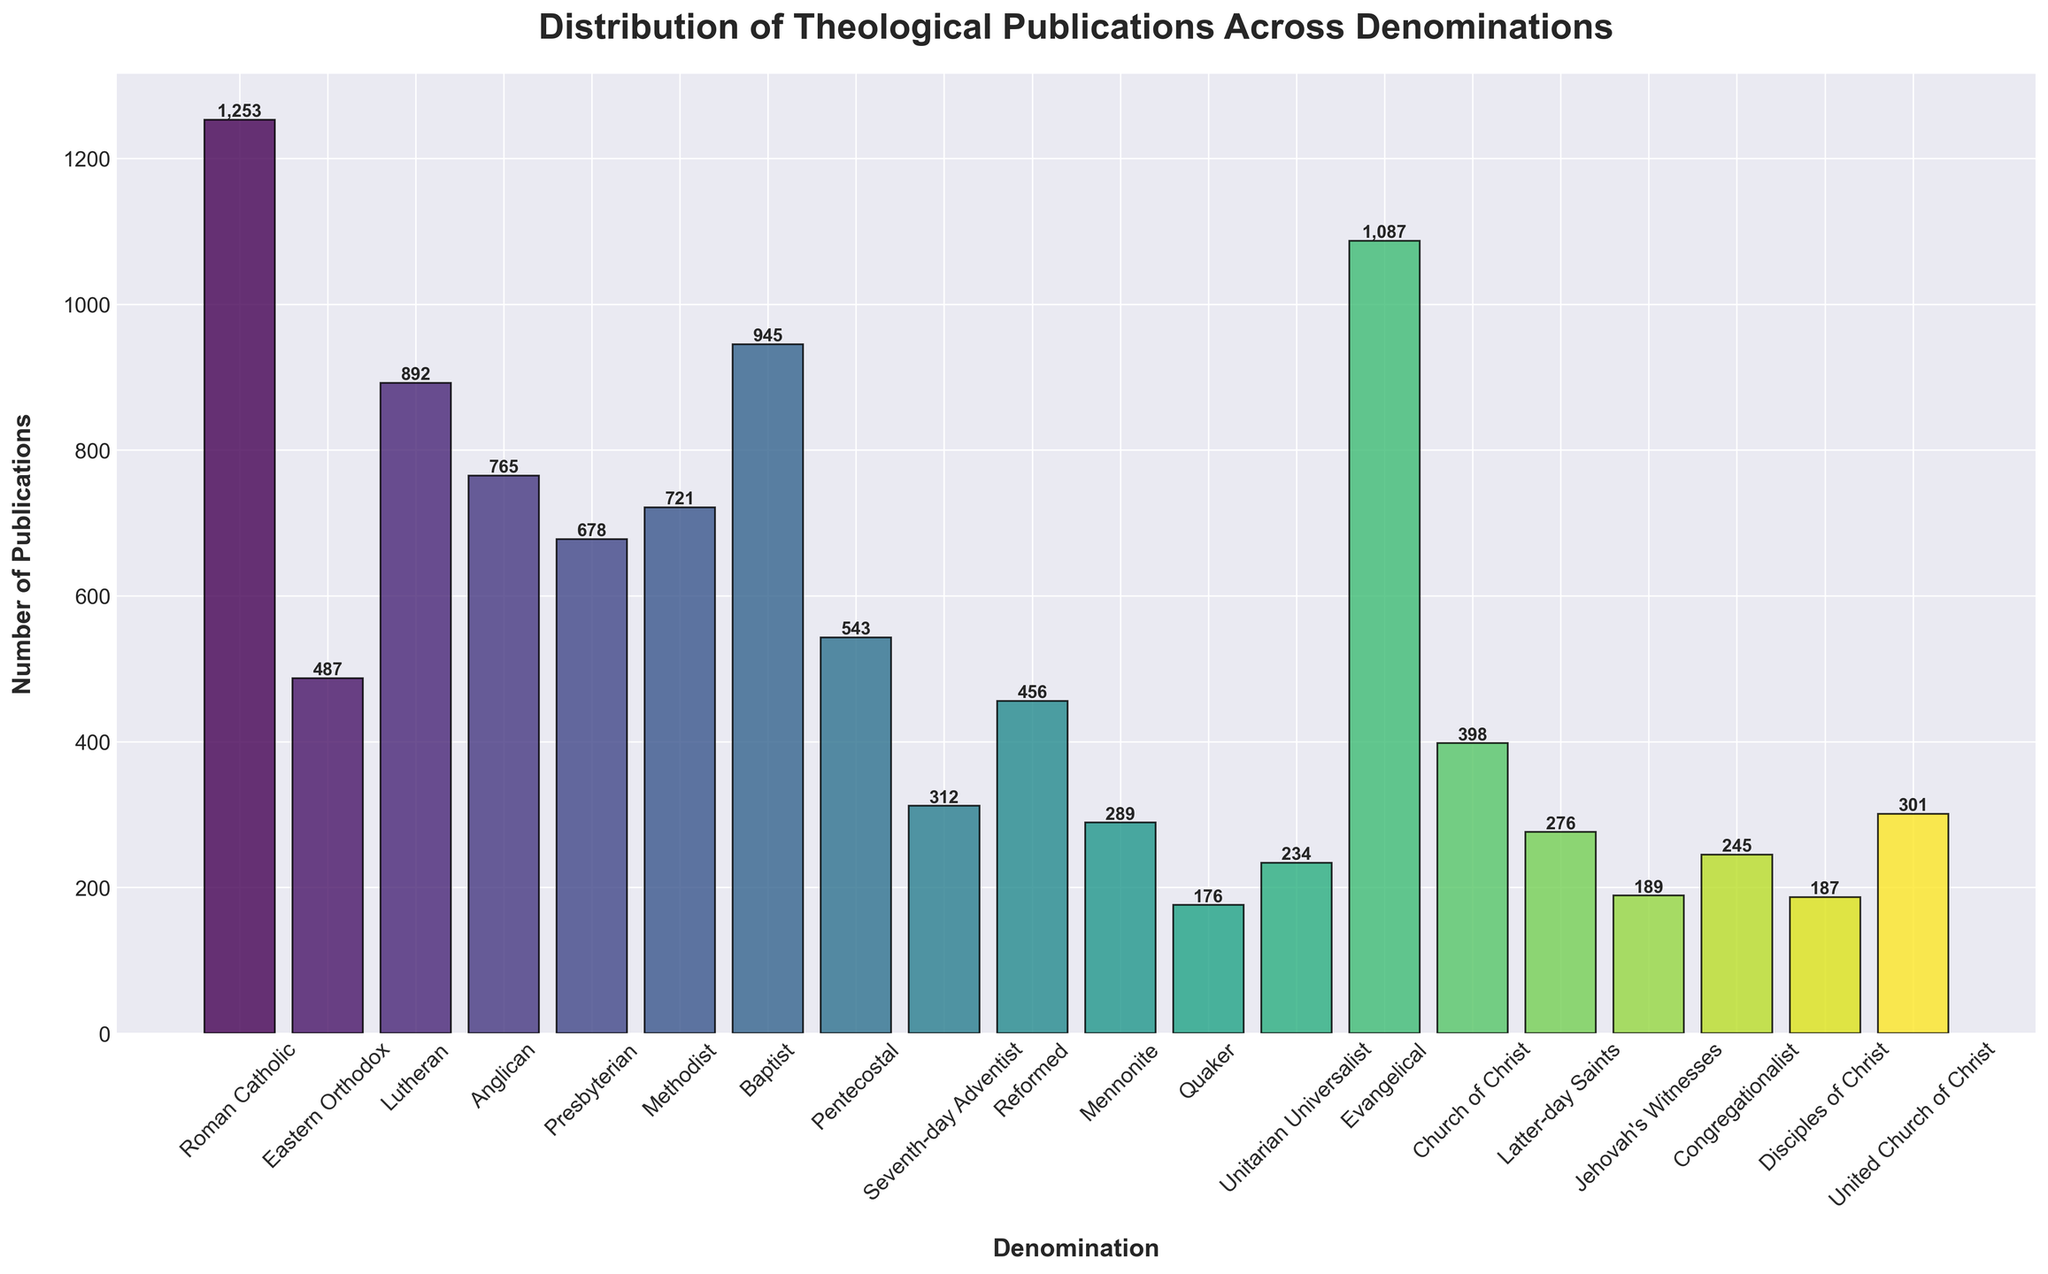Which denomination has the highest number of theological publications? The height of the bars indicates the number of publications for each denomination. The highest bar represents Roman Catholic with 1,253 publications.
Answer: Roman Catholic Which denomination has the lowest number of theological publications? The lowest bar height represents Quaker with 176 publications.
Answer: Quaker What is the total number of theological publications for Roman Catholic, Lutheran, and Baptist denominations combined? Add the values for Roman Catholic (1,253), Lutheran (892), and Baptist (945). The sum is 1,253 + 892 + 945 = 3,090.
Answer: 3,090 How does the number of publications for Methodist compare to that of Baptist? Compare the heights of the bars for Methodist (721) and Baptist (945). Baptist has more publications than Methodist.
Answer: Baptist has more Which denominations have a number of publications between 500 and 1000? Check bars with heights between 500 and 1000: Lutheran (892), Anglican (765), Methodist (721), Baptist (945), Eastern Orthodox (487), Pentecostal (543), and Evangelical (1,087, but it is slightly above 1000).
Answer: Lutheran, Anglican, Methodist, Baptist, Pentecostal Do more denominations have publications above 500 or below 500? Count bars above and below 500. There are more denominations above 500: 11 (Roman Catholic, Eastern Orthodox, Lutheran, Anglican, Presbyterian, Methodist, Baptist, Pentecostal, Evangelical, Church of Christ, United Church of Christ). Below 500: 9 (Seventh-day Adventist, Reformed, Mennonite, Quaker, Unitarian Universalist, Latter-day Saints, Jehovah's Witnesses, Congregationalist, Disciples of Christ).
Answer: More above 500 What is the difference in the number of publications between Evangelical and Anglican? Subtract the number of publications of Anglican (765) from Evangelical (1,087). 1,087 - 765 = 322.
Answer: 322 Which denomination has the closest number of publications to 500? Look for the bar heights around 500. The closest is Eastern Orthodox with 487 publications.
Answer: Eastern Orthodox If you combine the number of publications for Seventh-day Adventist and Reformed, does it exceed the number of publications by Baptist? Sum Seventh-day Adventist (312) and Reformed (456), then compare with Baptist (945). 312 + 456 = 768, which is less than 945.
Answer: No How many denominations have a number of publications greater than the median number of publications? Find each bar's publication number to determine the median manually. Sort the publications, the middle value is Methodist with 721 (since it's the median). Count denominations with publications above 721: Roman Catholic, Lutheran, Anglican, Baptist, Evangelical, Presbyterian, and Eastern Orthodox.
Answer: 7 